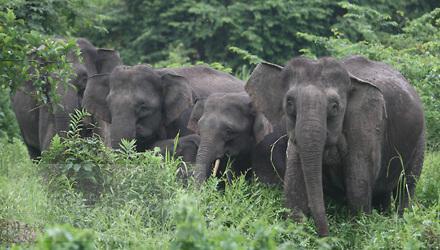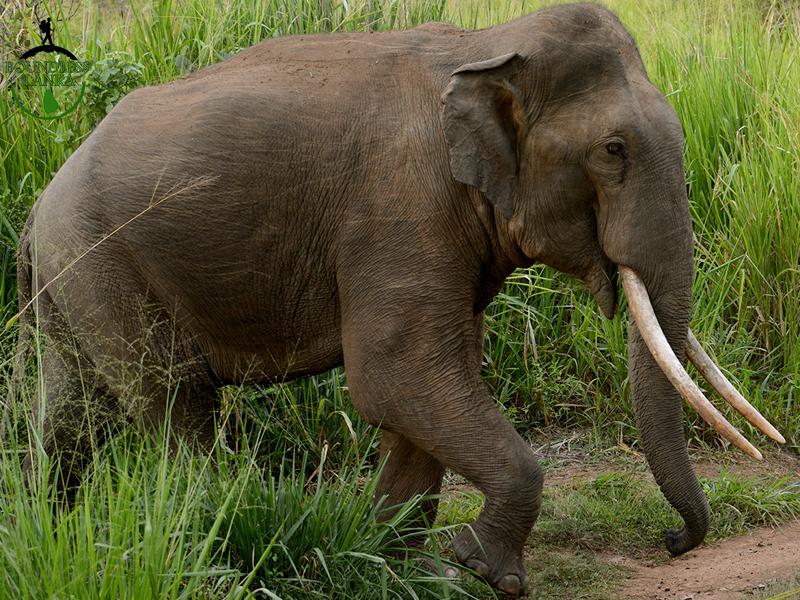The first image is the image on the left, the second image is the image on the right. Assess this claim about the two images: "The left image contains a baby elephant with an adult". Correct or not? Answer yes or no. No. The first image is the image on the left, the second image is the image on the right. Assess this claim about the two images: "In the right image the elephant has tusks". Correct or not? Answer yes or no. Yes. 